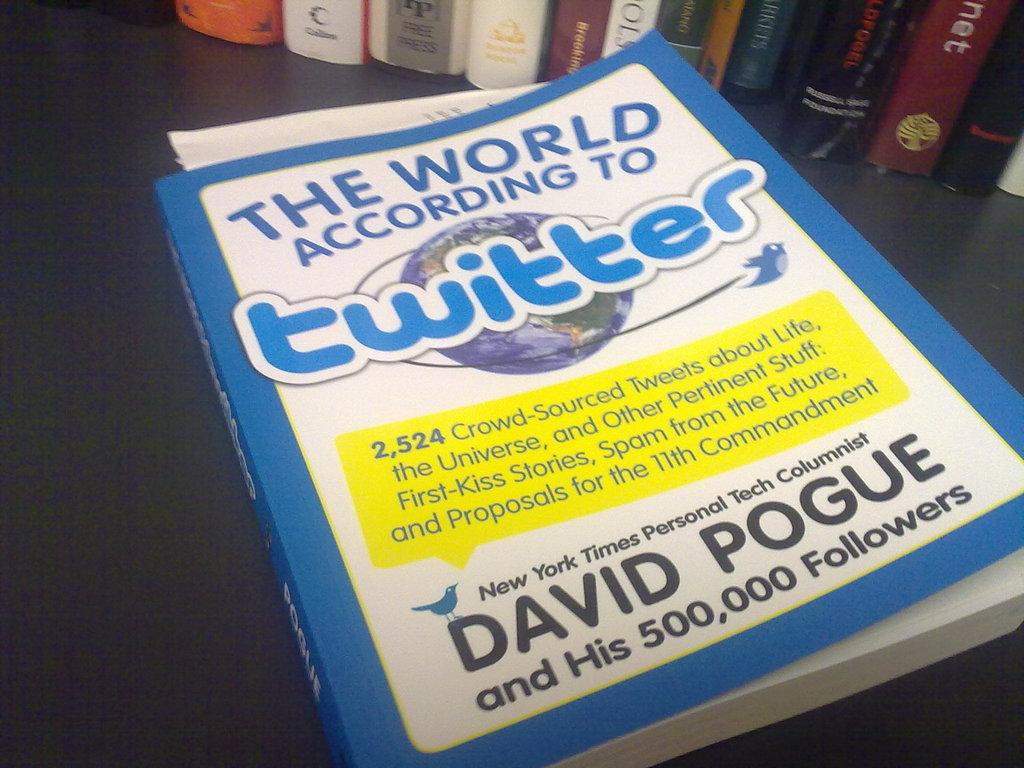<image>
Write a terse but informative summary of the picture. The World According to Twitter by David Pogue showing a picture of earth on the cover. 